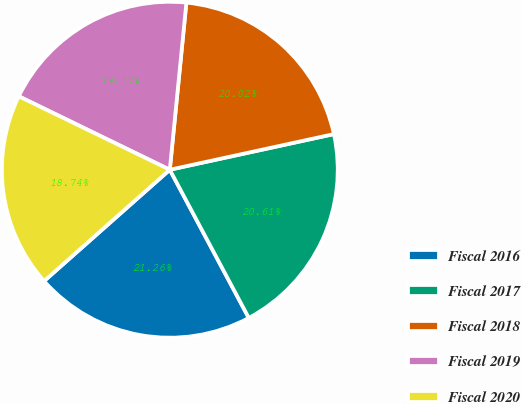Convert chart. <chart><loc_0><loc_0><loc_500><loc_500><pie_chart><fcel>Fiscal 2016<fcel>Fiscal 2017<fcel>Fiscal 2018<fcel>Fiscal 2019<fcel>Fiscal 2020<nl><fcel>21.26%<fcel>20.61%<fcel>20.02%<fcel>19.37%<fcel>18.74%<nl></chart> 